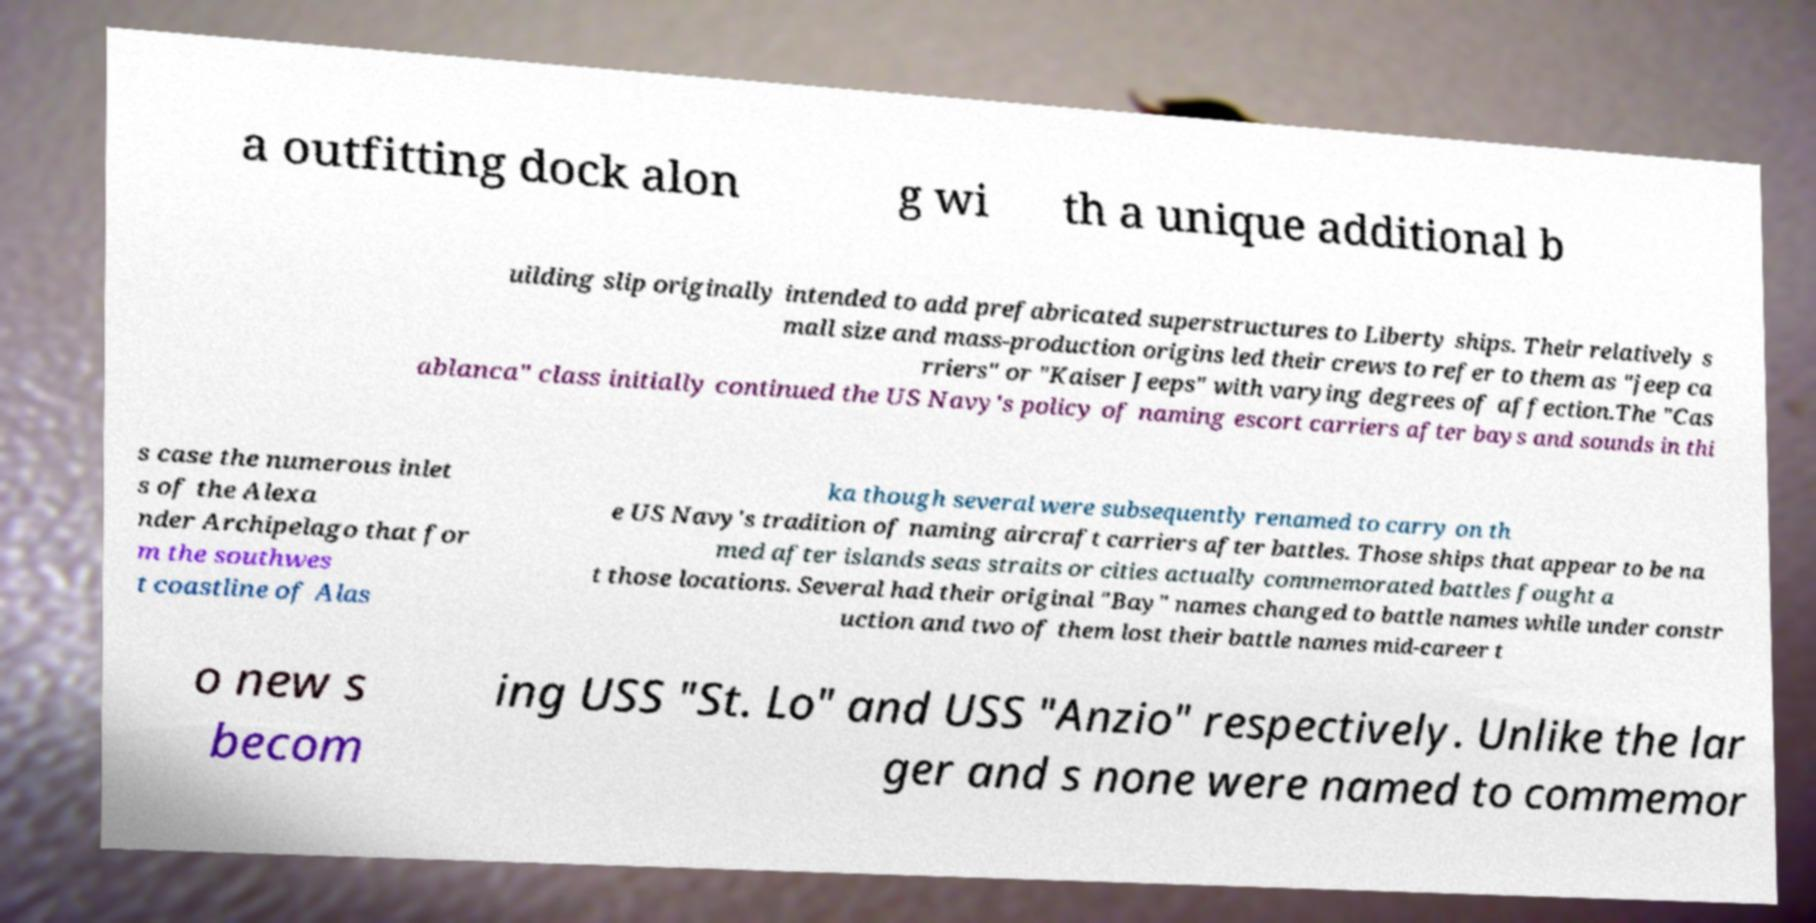Could you assist in decoding the text presented in this image and type it out clearly? a outfitting dock alon g wi th a unique additional b uilding slip originally intended to add prefabricated superstructures to Liberty ships. Their relatively s mall size and mass-production origins led their crews to refer to them as "jeep ca rriers" or "Kaiser Jeeps" with varying degrees of affection.The "Cas ablanca" class initially continued the US Navy's policy of naming escort carriers after bays and sounds in thi s case the numerous inlet s of the Alexa nder Archipelago that for m the southwes t coastline of Alas ka though several were subsequently renamed to carry on th e US Navy's tradition of naming aircraft carriers after battles. Those ships that appear to be na med after islands seas straits or cities actually commemorated battles fought a t those locations. Several had their original "Bay" names changed to battle names while under constr uction and two of them lost their battle names mid-career t o new s becom ing USS "St. Lo" and USS "Anzio" respectively. Unlike the lar ger and s none were named to commemor 